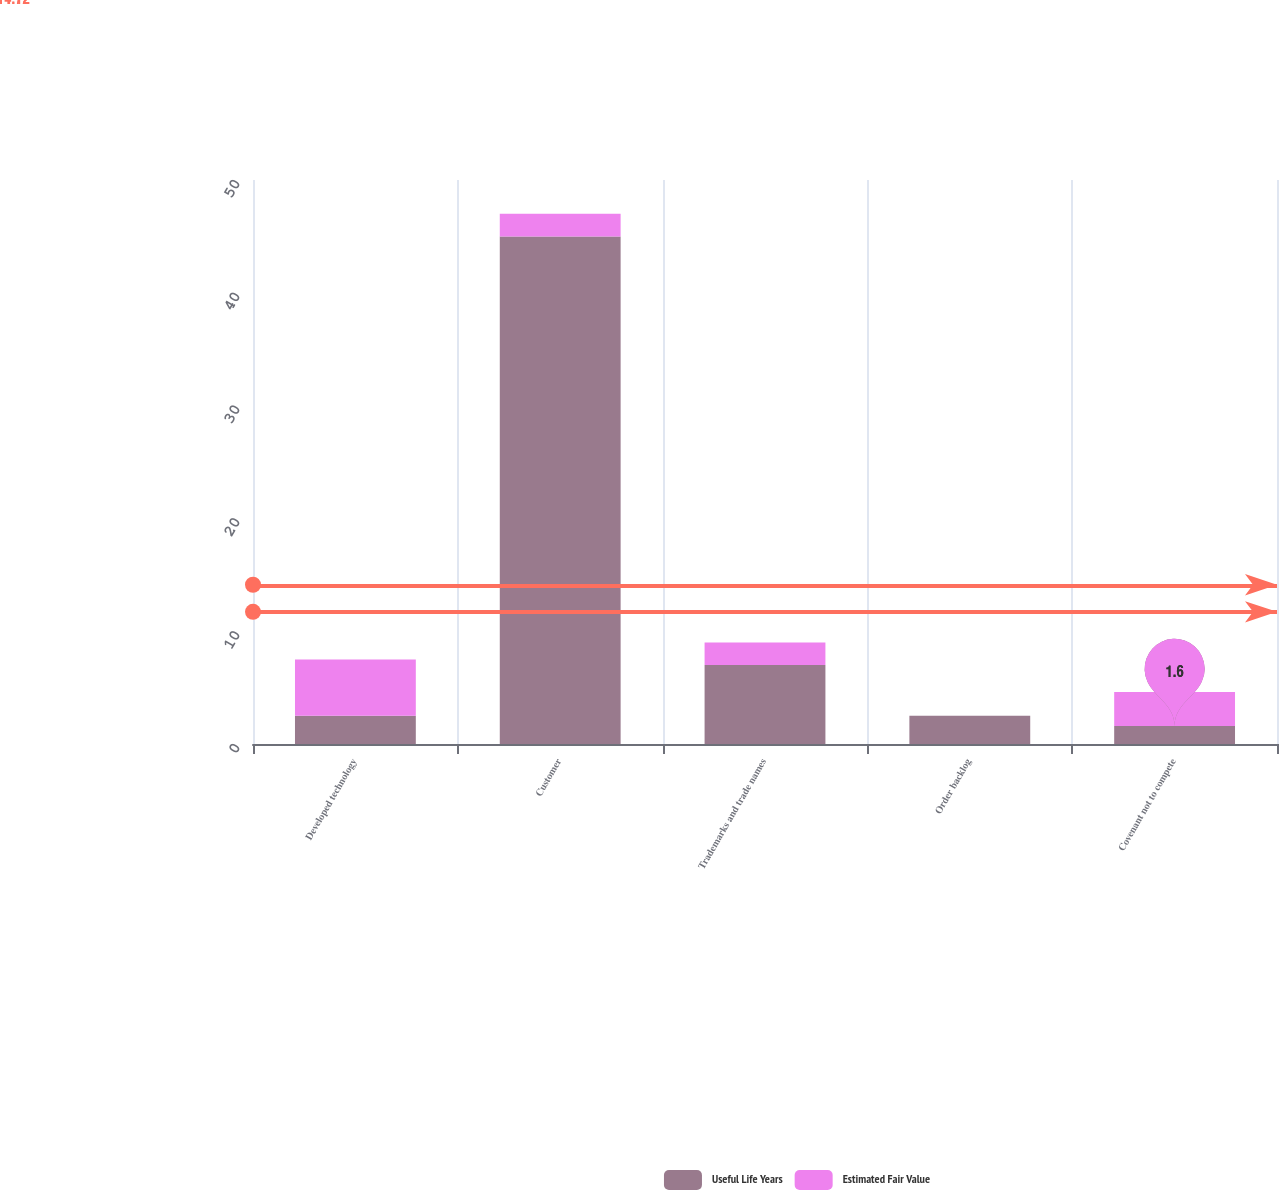Convert chart to OTSL. <chart><loc_0><loc_0><loc_500><loc_500><stacked_bar_chart><ecel><fcel>Developed technology<fcel>Customer<fcel>Trademarks and trade names<fcel>Order backlog<fcel>Covenant not to compete<nl><fcel>Useful Life Years<fcel>2.5<fcel>45<fcel>7<fcel>2.5<fcel>1.6<nl><fcel>Estimated Fair Value<fcel>5<fcel>2<fcel>2<fcel>0<fcel>3<nl></chart> 